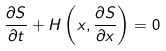<formula> <loc_0><loc_0><loc_500><loc_500>\frac { \partial S } { \partial t } + H \left ( x , \frac { \partial S } { \partial x } \right ) = 0</formula> 